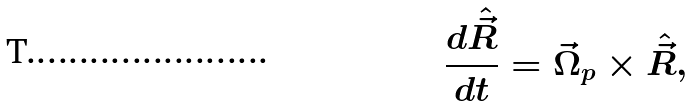<formula> <loc_0><loc_0><loc_500><loc_500>\frac { d \hat { \vec { R } } } { d t } = \vec { \Omega } _ { p } \times \hat { \vec { R } } ,</formula> 